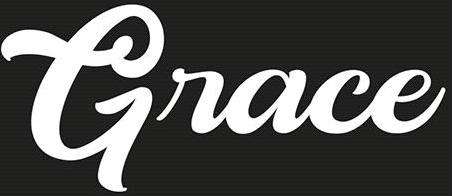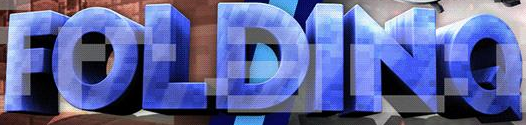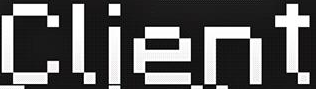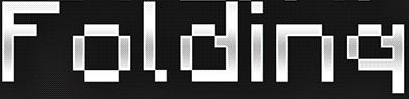Identify the words shown in these images in order, separated by a semicolon. Grace; FOLDINQ; Client; Folding 